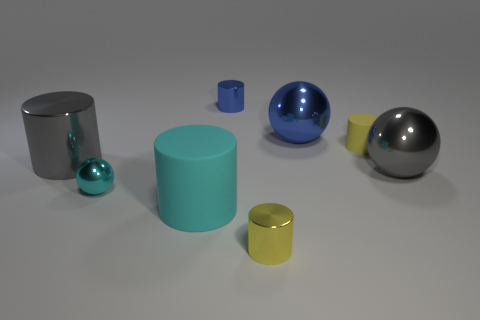Subtract all blue cylinders. How many cylinders are left? 4 Subtract all gray balls. How many balls are left? 2 Add 2 big metal spheres. How many objects exist? 10 Subtract all cylinders. How many objects are left? 3 Subtract all cyan matte cylinders. Subtract all tiny yellow things. How many objects are left? 5 Add 8 tiny yellow cylinders. How many tiny yellow cylinders are left? 10 Add 7 gray metal spheres. How many gray metal spheres exist? 8 Subtract 0 red spheres. How many objects are left? 8 Subtract 4 cylinders. How many cylinders are left? 1 Subtract all blue cylinders. Subtract all gray cubes. How many cylinders are left? 4 